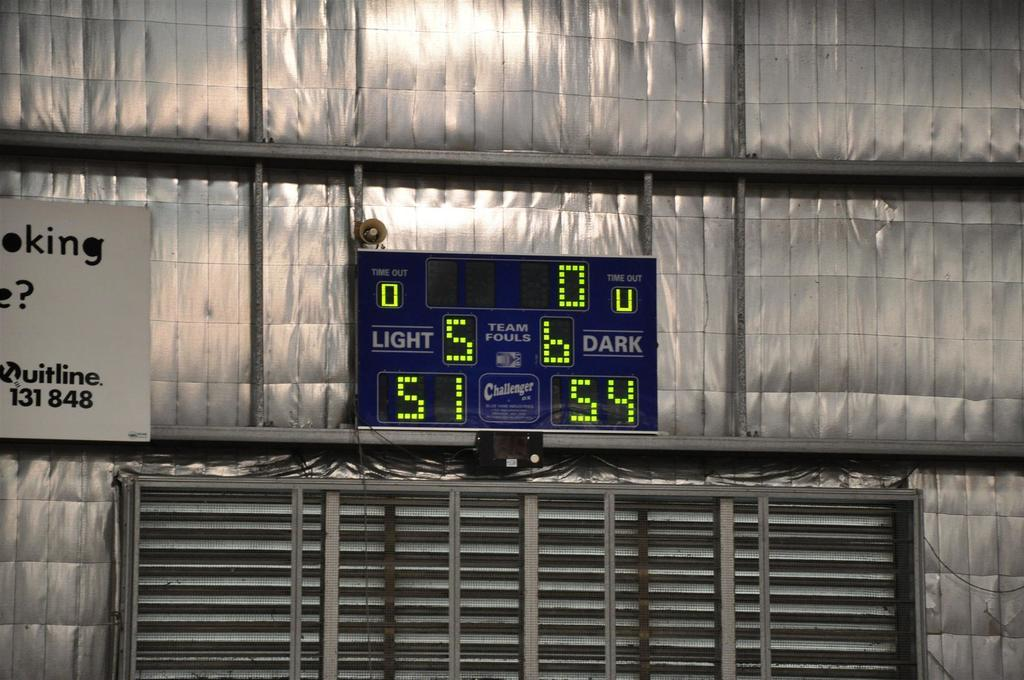<image>
Create a compact narrative representing the image presented. A score board displaying the score of 51 to 54. 